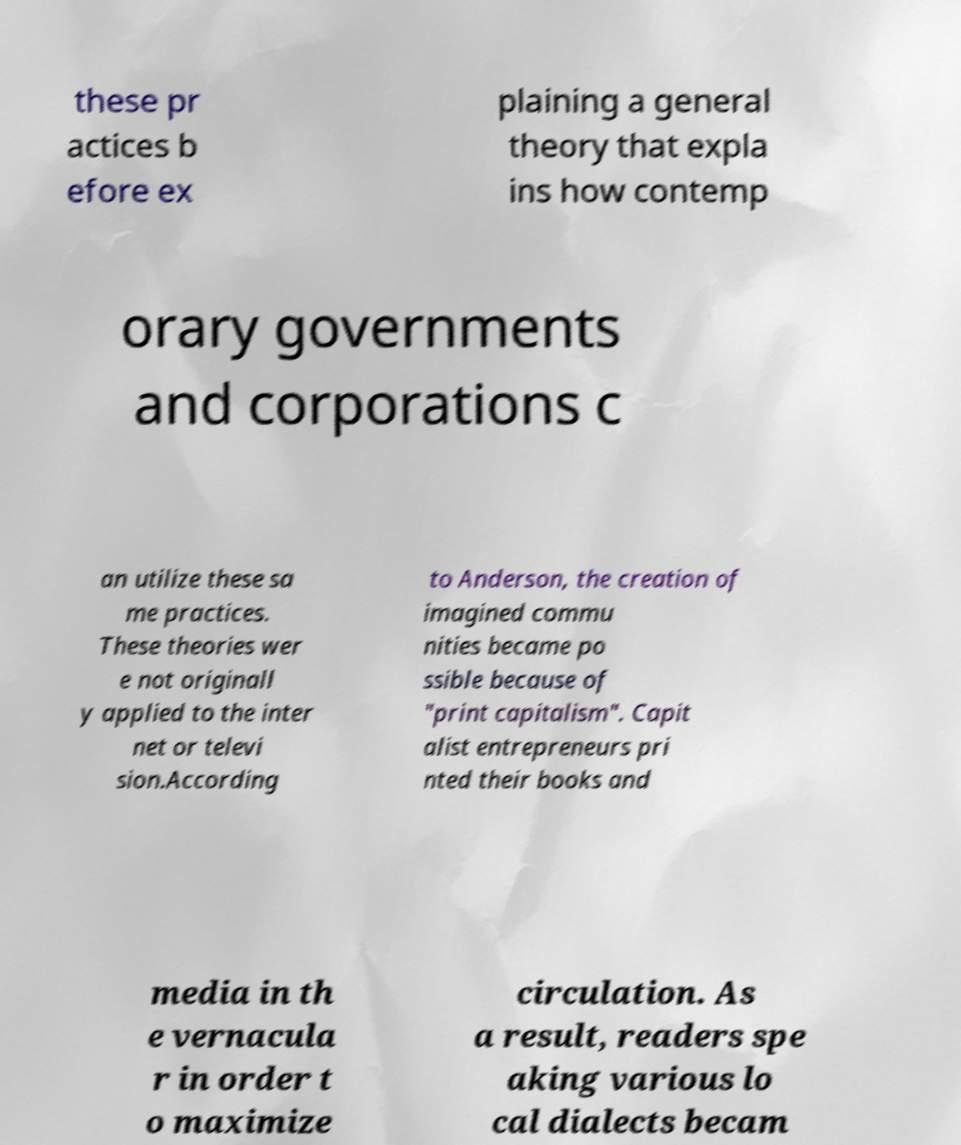Please read and relay the text visible in this image. What does it say? these pr actices b efore ex plaining a general theory that expla ins how contemp orary governments and corporations c an utilize these sa me practices. These theories wer e not originall y applied to the inter net or televi sion.According to Anderson, the creation of imagined commu nities became po ssible because of "print capitalism". Capit alist entrepreneurs pri nted their books and media in th e vernacula r in order t o maximize circulation. As a result, readers spe aking various lo cal dialects becam 